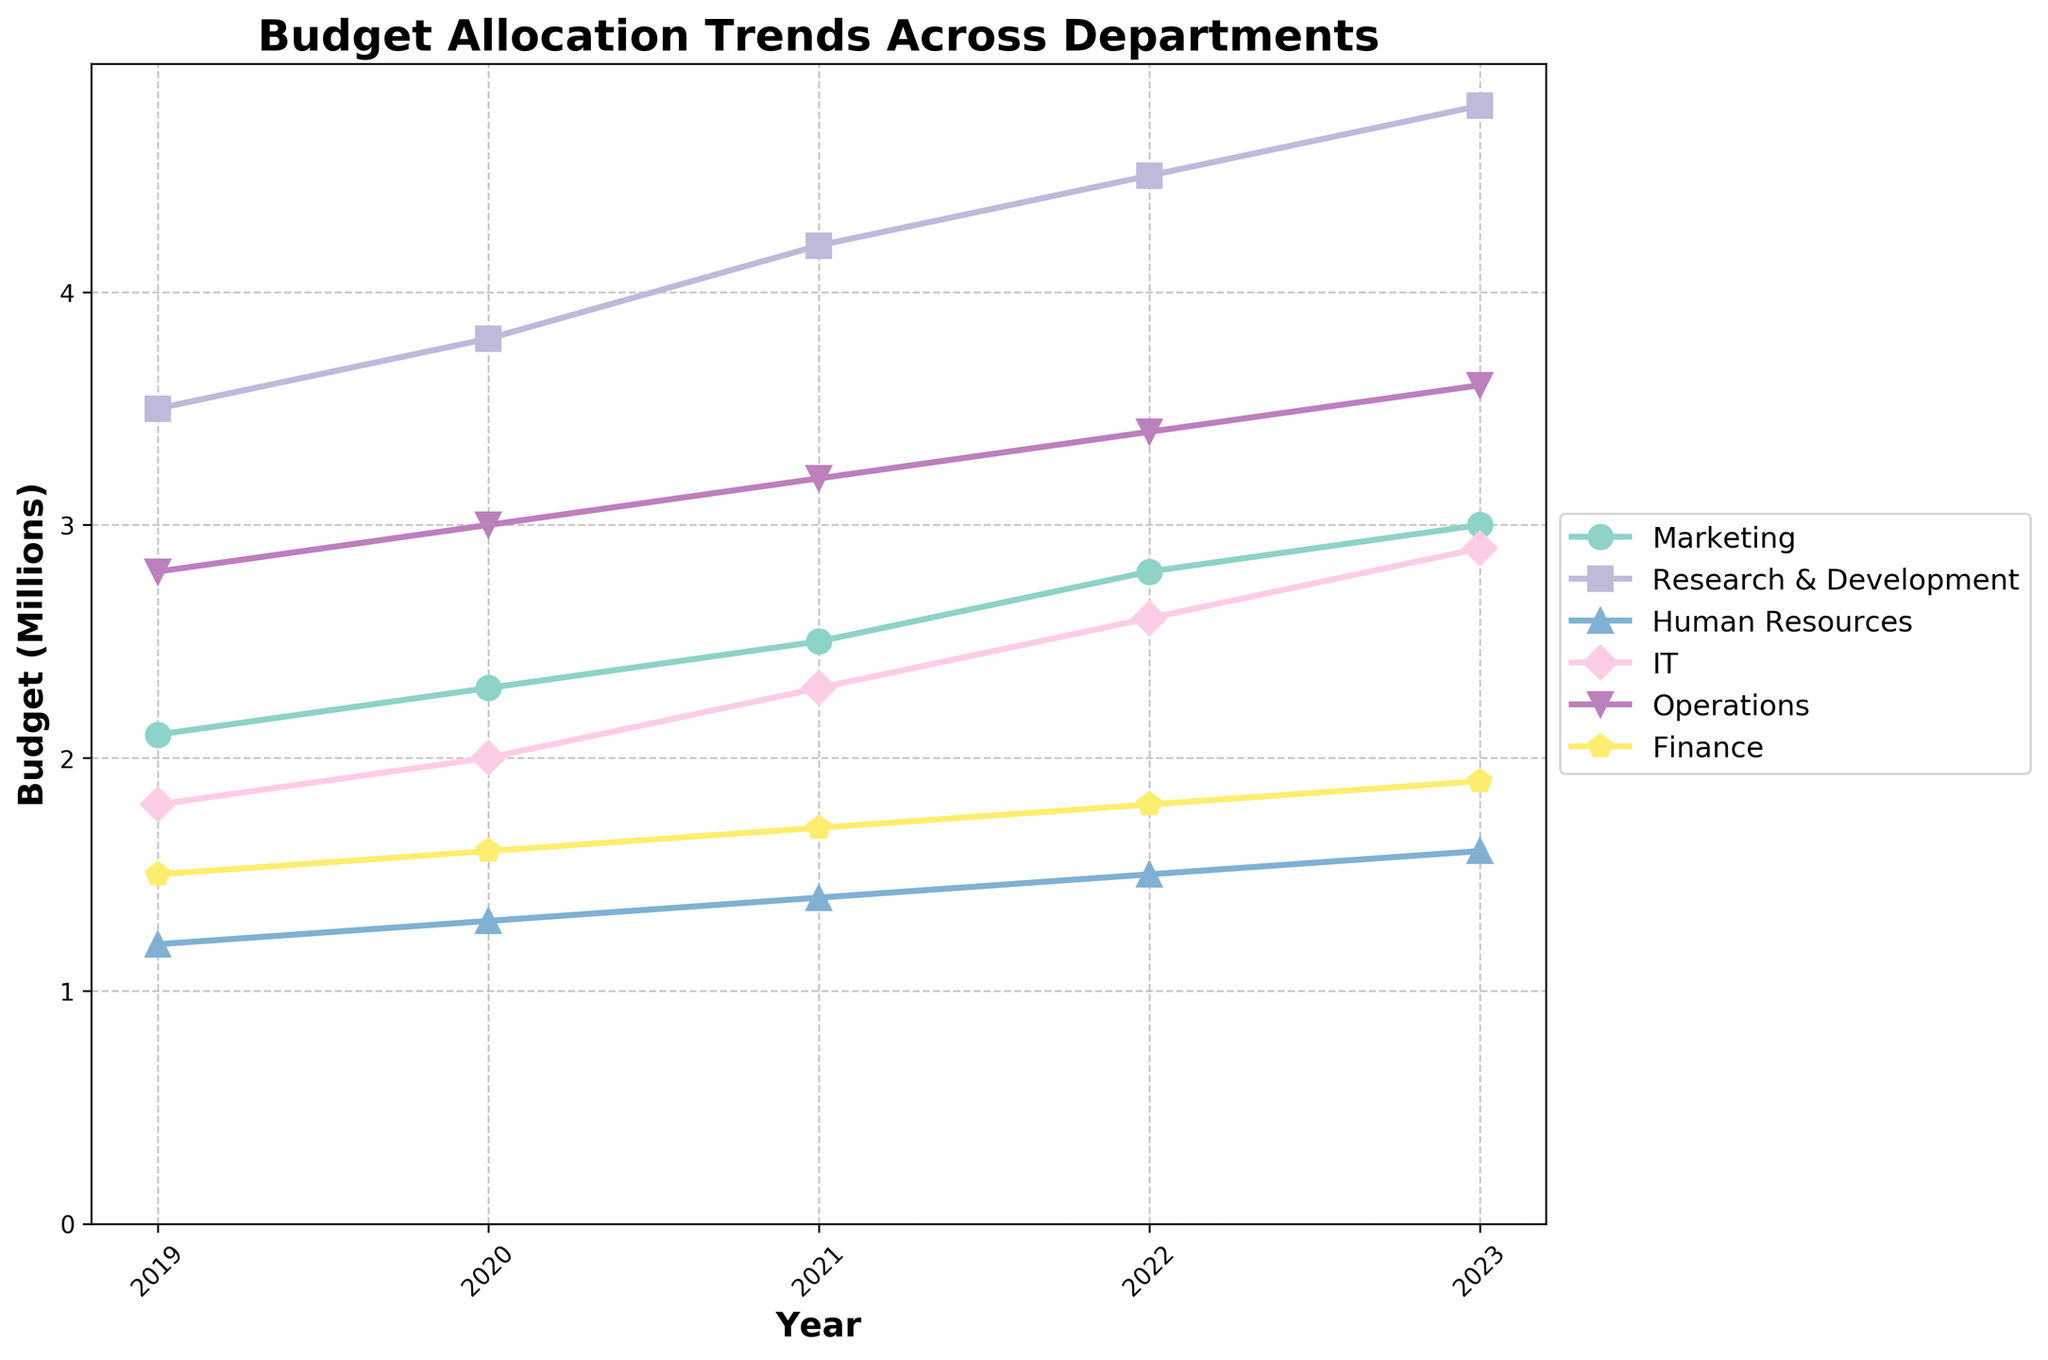Which department had the highest budget allocation in 2023? Look at the line for each department in the year 2023 and determine which line reaches the highest point. The Research & Development line appears at the top.
Answer: Research & Development What is the total budget allocation for IT over the 5 years? Sum the values of the IT budget from 2019 to 2023: (1,800,000 + 2,000,000 + 2,300,000 + 2,600,000 + 2,900,000).
Answer: 13,600,000 Which department showed the most growth in budget allocation from 2019 to 2023? Calculate the difference between 2019 and 2023 budgets for each department and find the largest difference. Research & Development went from 3,500,000 to 4,800,000, which is a 1,300,000 increase.
Answer: Research & Development How did the budget for Marketing in 2020 compare to that of Finance in the same year? Look at the values for Marketing and Finance in 2020 and compare: Marketing is 2,300,000 while Finance is 1,600,000.
Answer: Marketing had a higher budget What is the average annual budget for Operations over the 5 years? Sum the yearly budgets for Operations from 2019 to 2023 and divide by 5: (2,800,000 + 3,000,000 + 3,200,000 + 3,400,000 + 3,600,000) / 5.
Answer: 3,200,000 Which year saw the highest total budget allocation across all departments combined? Sum the budget allocations for all departments for each year and identify the highest total. The sums are: 12,100,000 (2019), 13,200,000 (2020), 14,300,000 (2021), 15,400,000 (2022), 16,500,000 (2023).
Answer: 2023 Did any department have a constant increase in budget allocation every year? Check the trend of budget values year-over-year for each department. Every department's budget increases steadily each year.
Answer: Yes How much more was the budget for Human Resources in 2023 compared to 2021? Subtract the 2021 budget from the 2023 budget for Human Resources: 1,600,000 - 1,400,000.
Answer: 200,000 